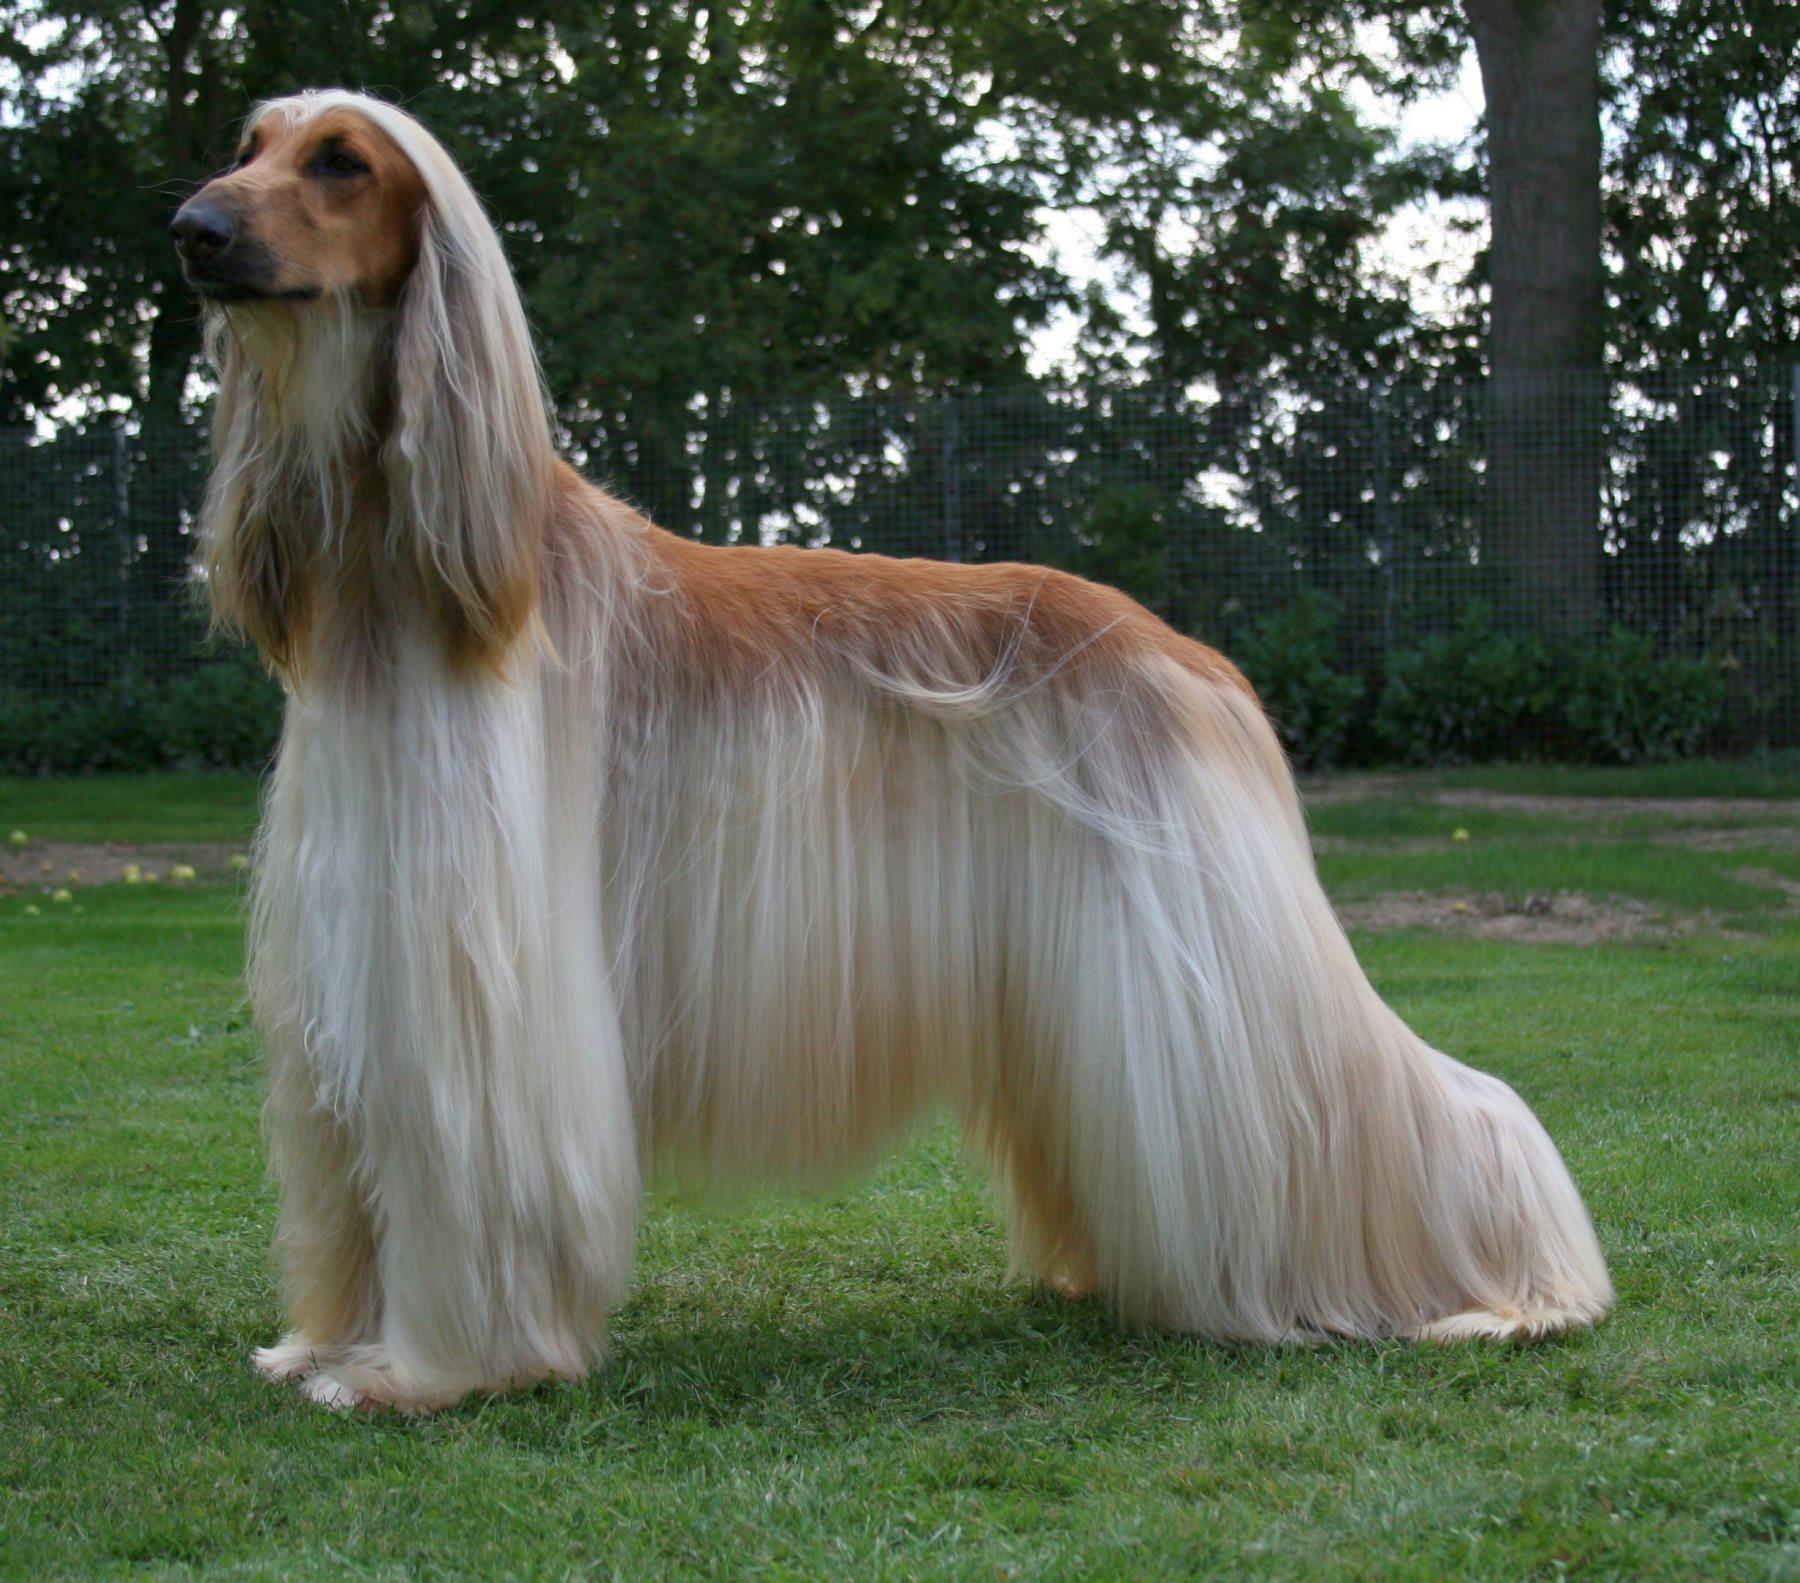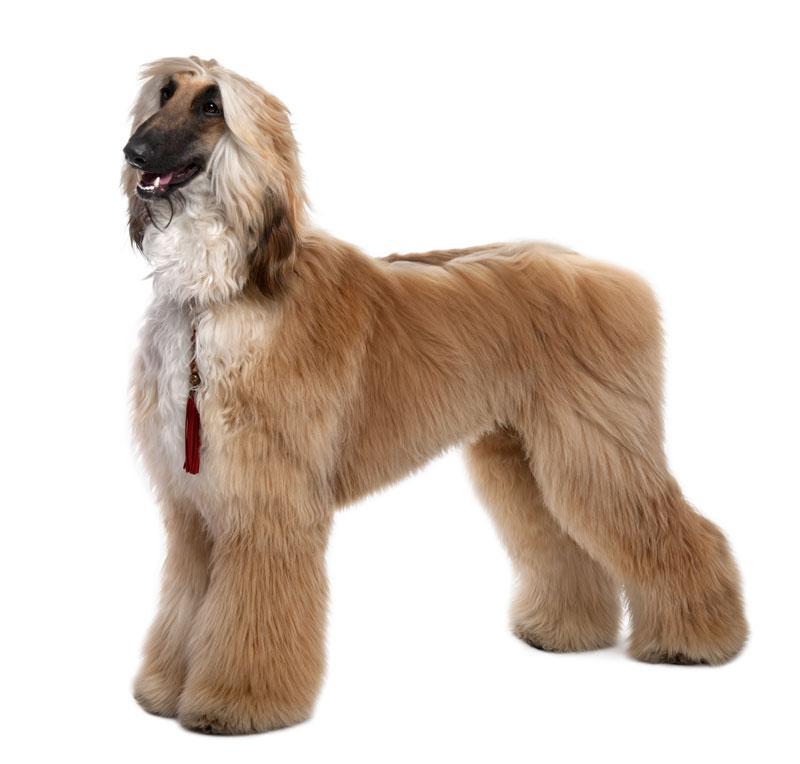The first image is the image on the left, the second image is the image on the right. Given the left and right images, does the statement "An image shows exactly one dog standing on all fours, and its fur is wavy-textured and dark grayish with paler markings." hold true? Answer yes or no. No. The first image is the image on the left, the second image is the image on the right. Considering the images on both sides, is "A dog in one of the images is lying down." valid? Answer yes or no. No. 